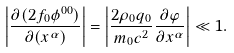Convert formula to latex. <formula><loc_0><loc_0><loc_500><loc_500>\left | \frac { \partial ( 2 f _ { 0 } \phi ^ { 0 0 } ) } { \partial ( x ^ { \alpha } ) } \right | = \left | \frac { 2 \rho _ { 0 } q _ { 0 } } { m _ { 0 } c ^ { 2 } } \frac { \partial \varphi } { \partial x ^ { \alpha } } \right | \ll 1 .</formula> 